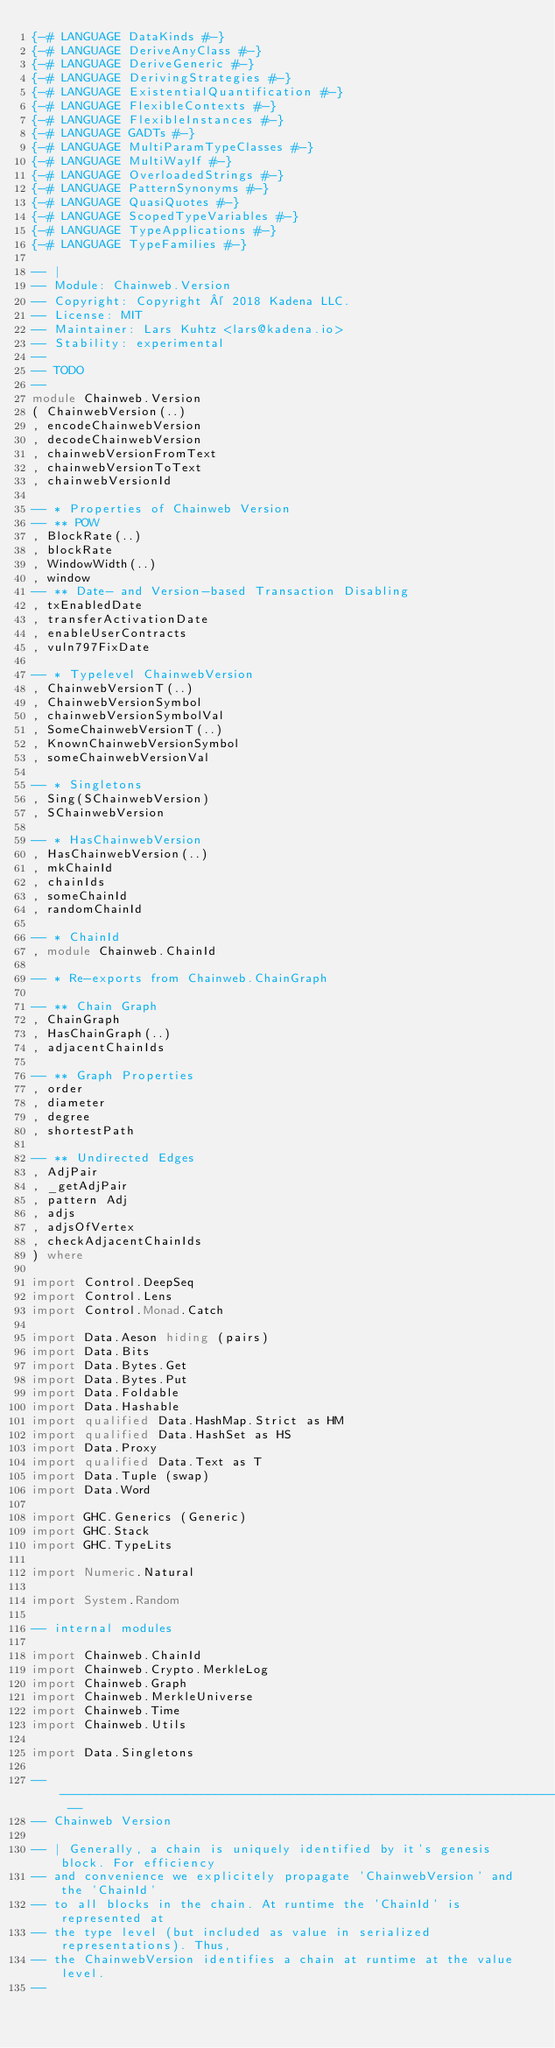<code> <loc_0><loc_0><loc_500><loc_500><_Haskell_>{-# LANGUAGE DataKinds #-}
{-# LANGUAGE DeriveAnyClass #-}
{-# LANGUAGE DeriveGeneric #-}
{-# LANGUAGE DerivingStrategies #-}
{-# LANGUAGE ExistentialQuantification #-}
{-# LANGUAGE FlexibleContexts #-}
{-# LANGUAGE FlexibleInstances #-}
{-# LANGUAGE GADTs #-}
{-# LANGUAGE MultiParamTypeClasses #-}
{-# LANGUAGE MultiWayIf #-}
{-# LANGUAGE OverloadedStrings #-}
{-# LANGUAGE PatternSynonyms #-}
{-# LANGUAGE QuasiQuotes #-}
{-# LANGUAGE ScopedTypeVariables #-}
{-# LANGUAGE TypeApplications #-}
{-# LANGUAGE TypeFamilies #-}

-- |
-- Module: Chainweb.Version
-- Copyright: Copyright © 2018 Kadena LLC.
-- License: MIT
-- Maintainer: Lars Kuhtz <lars@kadena.io>
-- Stability: experimental
--
-- TODO
--
module Chainweb.Version
( ChainwebVersion(..)
, encodeChainwebVersion
, decodeChainwebVersion
, chainwebVersionFromText
, chainwebVersionToText
, chainwebVersionId

-- * Properties of Chainweb Version
-- ** POW
, BlockRate(..)
, blockRate
, WindowWidth(..)
, window
-- ** Date- and Version-based Transaction Disabling
, txEnabledDate
, transferActivationDate
, enableUserContracts
, vuln797FixDate

-- * Typelevel ChainwebVersion
, ChainwebVersionT(..)
, ChainwebVersionSymbol
, chainwebVersionSymbolVal
, SomeChainwebVersionT(..)
, KnownChainwebVersionSymbol
, someChainwebVersionVal

-- * Singletons
, Sing(SChainwebVersion)
, SChainwebVersion

-- * HasChainwebVersion
, HasChainwebVersion(..)
, mkChainId
, chainIds
, someChainId
, randomChainId

-- * ChainId
, module Chainweb.ChainId

-- * Re-exports from Chainweb.ChainGraph

-- ** Chain Graph
, ChainGraph
, HasChainGraph(..)
, adjacentChainIds

-- ** Graph Properties
, order
, diameter
, degree
, shortestPath

-- ** Undirected Edges
, AdjPair
, _getAdjPair
, pattern Adj
, adjs
, adjsOfVertex
, checkAdjacentChainIds
) where

import Control.DeepSeq
import Control.Lens
import Control.Monad.Catch

import Data.Aeson hiding (pairs)
import Data.Bits
import Data.Bytes.Get
import Data.Bytes.Put
import Data.Foldable
import Data.Hashable
import qualified Data.HashMap.Strict as HM
import qualified Data.HashSet as HS
import Data.Proxy
import qualified Data.Text as T
import Data.Tuple (swap)
import Data.Word

import GHC.Generics (Generic)
import GHC.Stack
import GHC.TypeLits

import Numeric.Natural

import System.Random

-- internal modules

import Chainweb.ChainId
import Chainweb.Crypto.MerkleLog
import Chainweb.Graph
import Chainweb.MerkleUniverse
import Chainweb.Time
import Chainweb.Utils

import Data.Singletons

-- -------------------------------------------------------------------------- --
-- Chainweb Version

-- | Generally, a chain is uniquely identified by it's genesis block. For efficiency
-- and convenience we explicitely propagate 'ChainwebVersion' and the 'ChainId'
-- to all blocks in the chain. At runtime the 'ChainId' is represented at
-- the type level (but included as value in serialized representations). Thus,
-- the ChainwebVersion identifies a chain at runtime at the value level.
--</code> 